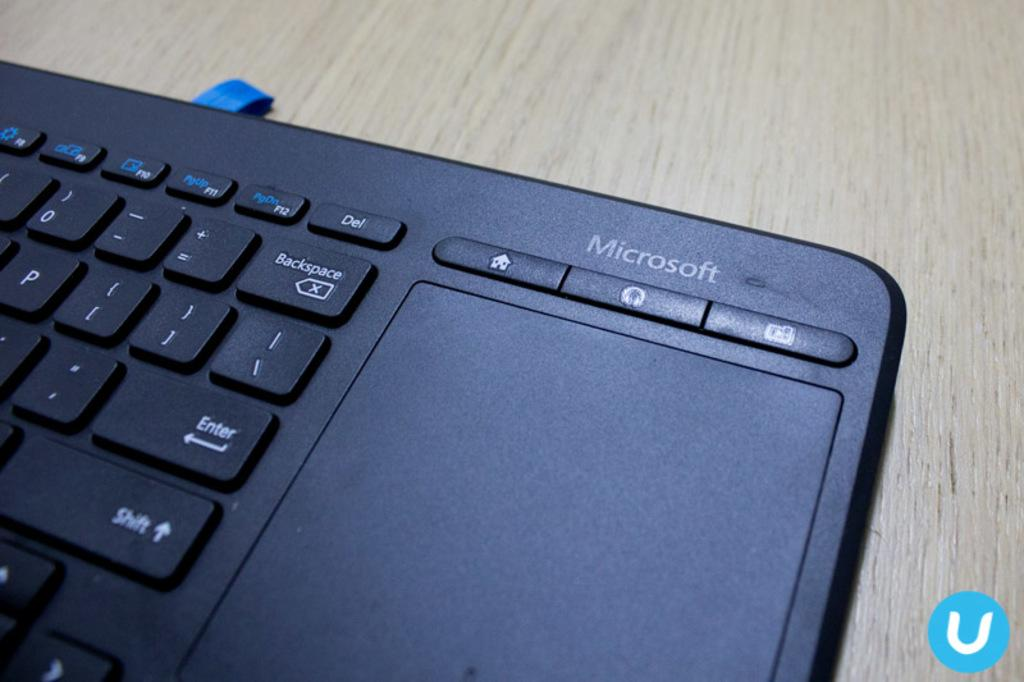Provide a one-sentence caption for the provided image. A Microsoft keyboard that has a trackpad on it. 